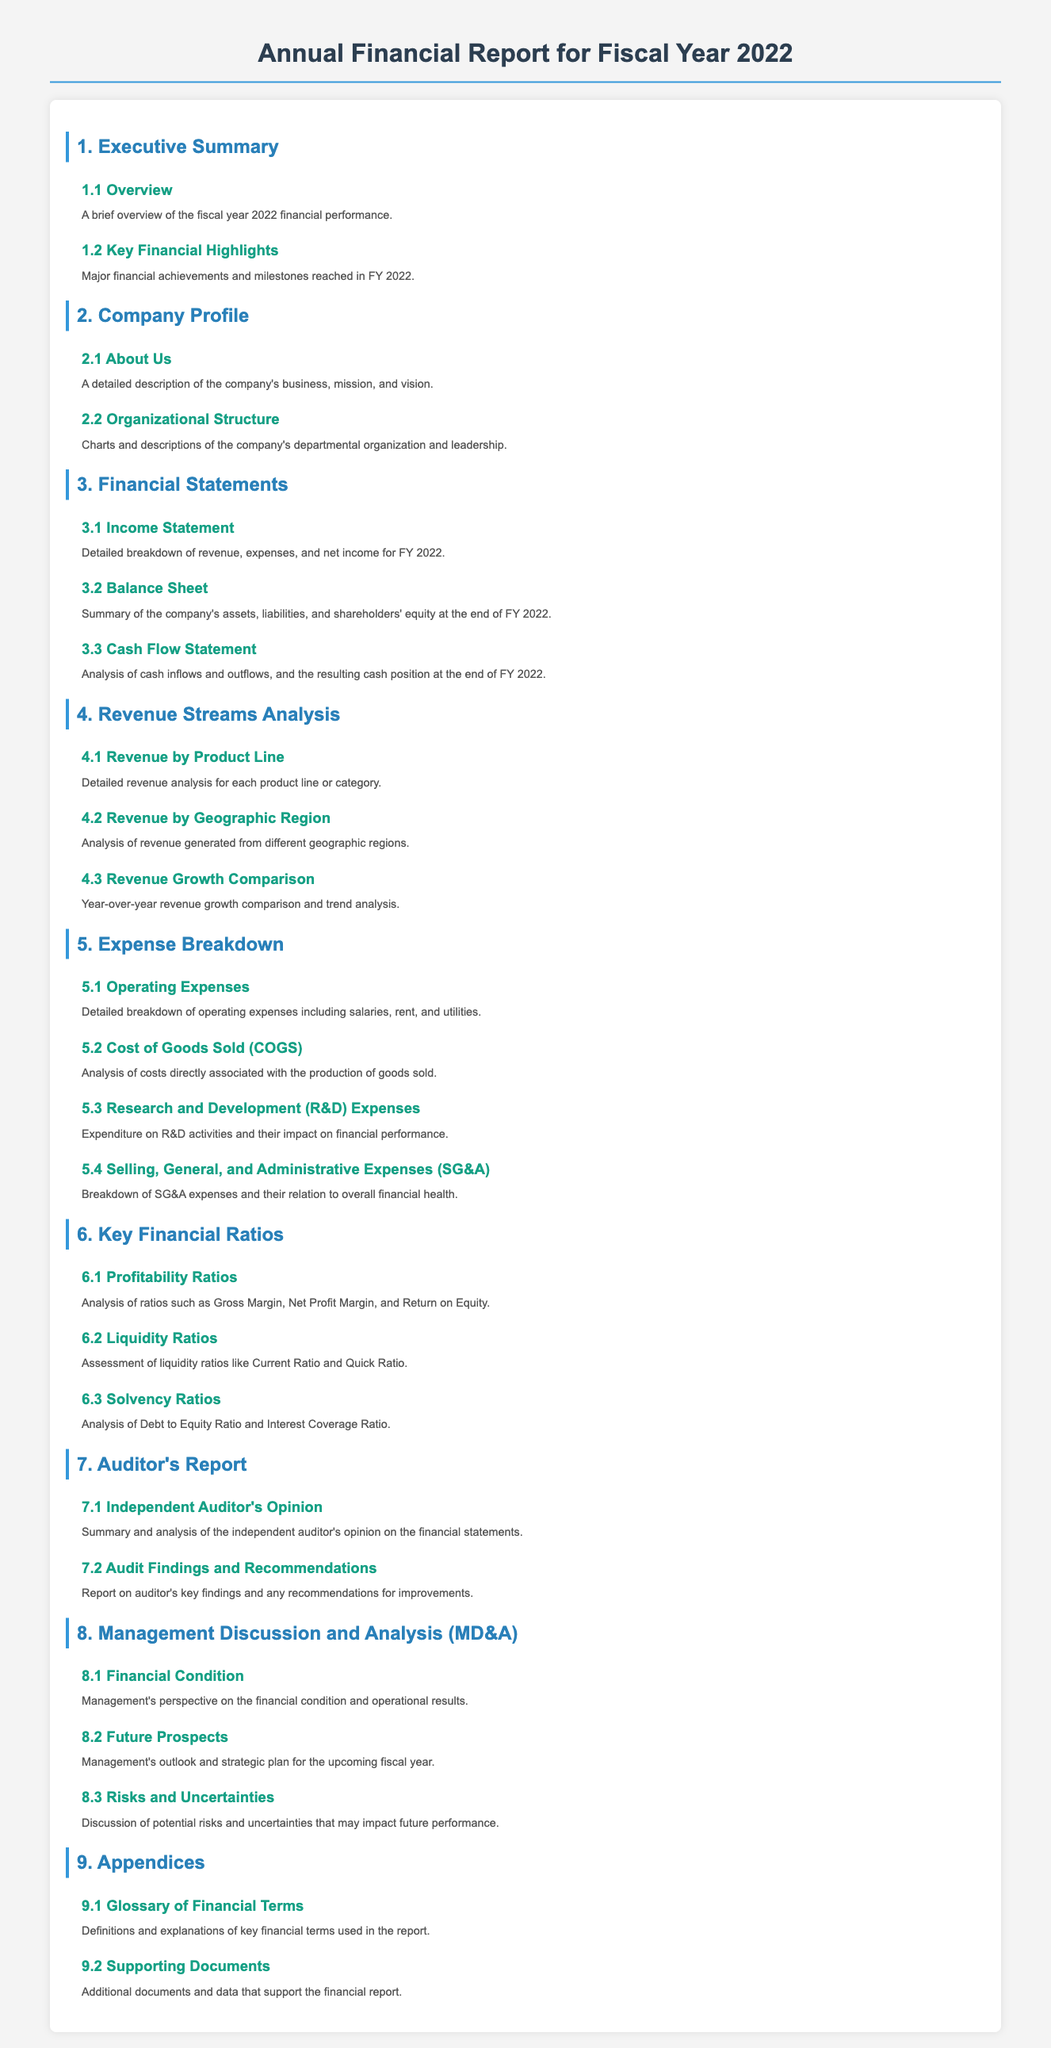What section includes a brief overview of financial performance? The section titled "1.1 Overview" provides a brief overview of financial performance for the fiscal year.
Answer: 1.1 Overview Which section discusses revenue generated from different geographic regions? Section "4.2 Revenue by Geographic Region" is dedicated to analyzing revenue from various regions.
Answer: 4.2 Revenue by Geographic Region What does the "5.1" section focus on? The section "5.1 Operating Expenses" provides a detailed breakdown of operating expenses incurred by the company.
Answer: 5.1 Operating Expenses What key financial ratio assesses liquidity? The "6.2 Liquidity Ratios" section analyzes liquidity ratios, including Current Ratio and Quick Ratio, to evaluate financial health.
Answer: 6.2 Liquidity Ratios What does the Auditor's Report summarize? The "7.1 Independent Auditor's Opinion" section summarises the independent auditor's opinion on the financial statements.
Answer: 7.1 Independent Auditor's Opinion Which section predicts future financial prospects? The section "8.2 Future Prospects" discusses management's outlook and strategic plan for the upcoming fiscal year.
Answer: 8.2 Future Prospects What is covered in the "9.1" section? The section "9.1 Glossary of Financial Terms" defines and explains key financial terms used throughout the report.
Answer: 9.1 Glossary of Financial Terms What was a major financial achievement highlighted in the report? The title "1.2 Key Financial Highlights" suggests that major achievements and milestones reached in FY 2022 are detailed in this section.
Answer: 1.2 Key Financial Highlights What are the two main categories analyzed in the Expense Breakdown section? The section "5. Expense Breakdown" includes operating expenses and Cost of Goods Sold as its main categories.
Answer: Operating Expenses and Cost of Goods Sold 